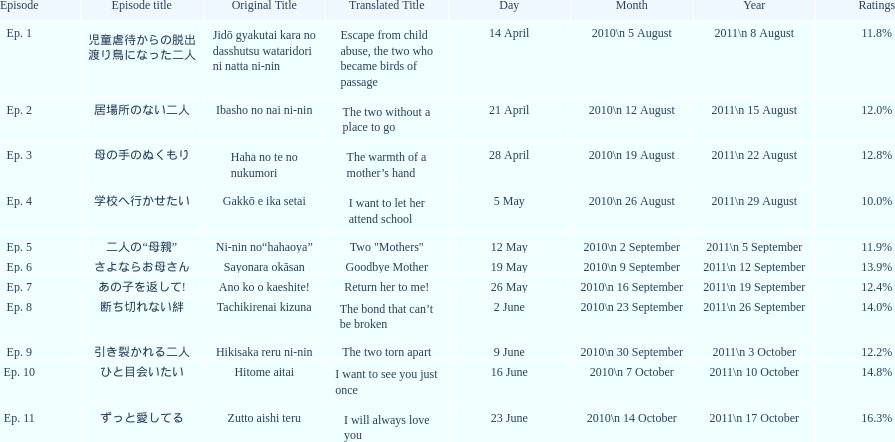Other than the 10th episode, which other episode has a 14% rating? Ep. 8. 